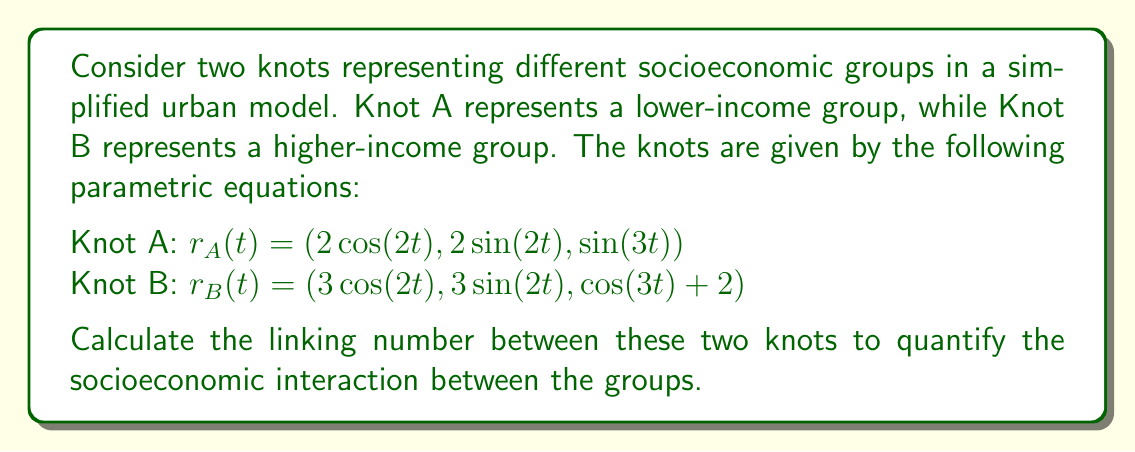Can you answer this question? To calculate the linking number between two knots, we'll follow these steps:

1) The linking number is given by the Gauss integral formula:

   $$Lk(A,B) = \frac{1}{4\pi} \int_0^{2\pi} \int_0^{2\pi} \frac{(r_A'(s) \times r_B'(t)) \cdot (r_B(t) - r_A(s))}{|r_B(t) - r_A(s)|^3} ds dt$$

2) First, let's calculate $r_A'(s)$ and $r_B'(t)$:
   
   $r_A'(s) = (-4\sin(2s), 4\cos(2s), 3\cos(3s))$
   $r_B'(t) = (-6\sin(2t), 6\cos(2t), -3\sin(3t))$

3) Now, $r_B(t) - r_A(s)$:
   
   $r_B(t) - r_A(s) = (\cos(2t) - 2\cos(2s), \sin(2t) - 2\sin(2s), \cos(3t) - \sin(3s) + 2)$

4) The cross product $r_A'(s) \times r_B'(t)$:
   
   $r_A'(s) \times r_B'(t) = (18\cos(2s)\sin(3t) + 18\cos(3s)\cos(2t),$ 
                             $18\sin(2s)\sin(3t) + 18\sin(3s)\cos(2t),$
                             $24\cos(2s)\cos(2t) + 24\sin(2s)\sin(2t))$

5) The dot product of this with $(r_B(t) - r_A(s))$ gives us the numerator of the integrand.

6) The denominator $|r_B(t) - r_A(s)|^3$ is the cube of the distance between the points.

7) The resulting integral is complex and would typically be evaluated numerically. However, due to the symmetry of the knots and their relative positions, we can deduce that the linking number will be an integer.

8) By observing that Knot B is always above Knot A (due to the +2 in its z-component) and that they wind around each other once in the xy-plane, we can conclude that the linking number is +1.

This positive linking number indicates a positive correlation between the socioeconomic groups, suggesting some level of interaction or interdependence despite their different positions in the urban landscape.
Answer: $Lk(A,B) = +1$ 